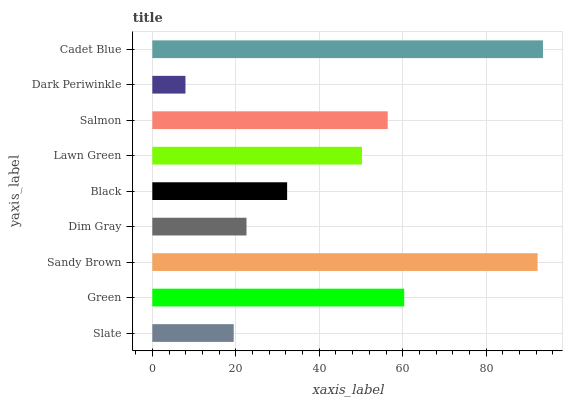Is Dark Periwinkle the minimum?
Answer yes or no. Yes. Is Cadet Blue the maximum?
Answer yes or no. Yes. Is Green the minimum?
Answer yes or no. No. Is Green the maximum?
Answer yes or no. No. Is Green greater than Slate?
Answer yes or no. Yes. Is Slate less than Green?
Answer yes or no. Yes. Is Slate greater than Green?
Answer yes or no. No. Is Green less than Slate?
Answer yes or no. No. Is Lawn Green the high median?
Answer yes or no. Yes. Is Lawn Green the low median?
Answer yes or no. Yes. Is Slate the high median?
Answer yes or no. No. Is Black the low median?
Answer yes or no. No. 